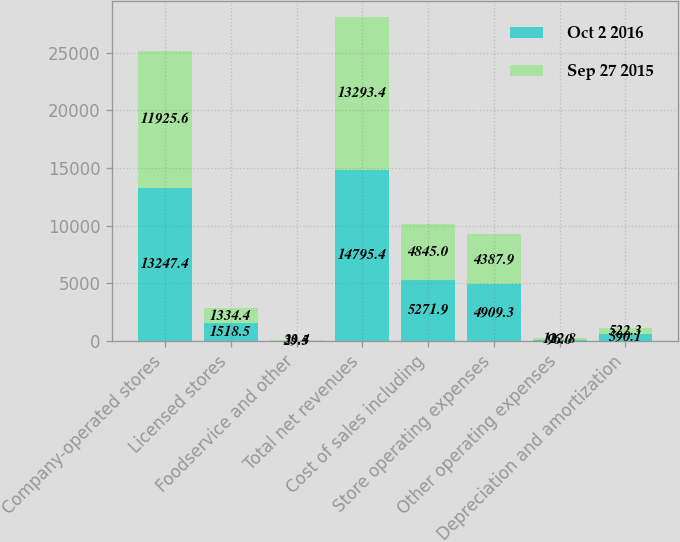<chart> <loc_0><loc_0><loc_500><loc_500><stacked_bar_chart><ecel><fcel>Company-operated stores<fcel>Licensed stores<fcel>Foodservice and other<fcel>Total net revenues<fcel>Cost of sales including<fcel>Store operating expenses<fcel>Other operating expenses<fcel>Depreciation and amortization<nl><fcel>Oct 2 2016<fcel>13247.4<fcel>1518.5<fcel>29.5<fcel>14795.4<fcel>5271.9<fcel>4909.3<fcel>96<fcel>590.1<nl><fcel>Sep 27 2015<fcel>11925.6<fcel>1334.4<fcel>33.4<fcel>13293.4<fcel>4845<fcel>4387.9<fcel>122.8<fcel>522.3<nl></chart> 